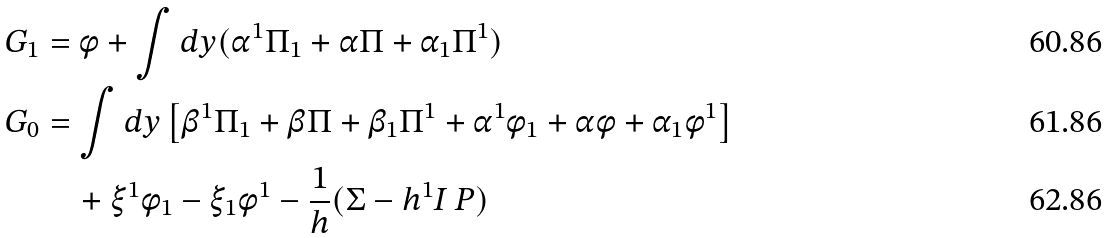<formula> <loc_0><loc_0><loc_500><loc_500>G _ { 1 } & = \phi + \int d y ( \alpha ^ { 1 } \Pi _ { 1 } + \alpha \Pi + \alpha _ { 1 } \Pi ^ { 1 } ) \\ G _ { 0 } & = \int d y \left [ \beta ^ { 1 } \Pi _ { 1 } + \beta \Pi + \beta _ { 1 } \Pi ^ { 1 } + \alpha ^ { 1 } \phi _ { 1 } + \alpha \phi + \alpha _ { 1 } \phi ^ { 1 } \right ] \\ & \quad + \xi ^ { 1 } \phi _ { 1 } - \xi _ { 1 } \phi ^ { 1 } - \frac { 1 } { h } ( \Sigma - h ^ { 1 } I \, P )</formula> 